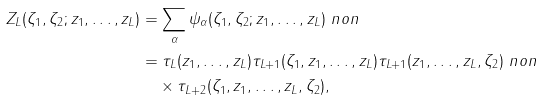<formula> <loc_0><loc_0><loc_500><loc_500>Z _ { L } ( \zeta _ { 1 } , \zeta _ { 2 } ; z _ { 1 } , \dots , z _ { L } ) & = \sum _ { \alpha } \psi _ { \alpha } ( \zeta _ { 1 } , \zeta _ { 2 } ; z _ { 1 } , \dots , z _ { L } ) \ n o n \\ & = \tau _ { L } ( z _ { 1 } , \dots , z _ { L } ) \tau _ { L + 1 } ( \zeta _ { 1 } , z _ { 1 } , \dots , z _ { L } ) \tau _ { L + 1 } ( z _ { 1 } , \dots , z _ { L } , \zeta _ { 2 } ) \ n o n \\ & \quad \times \tau _ { L + 2 } ( \zeta _ { 1 } , z _ { 1 } , \dots , z _ { L } , \zeta _ { 2 } ) ,</formula> 